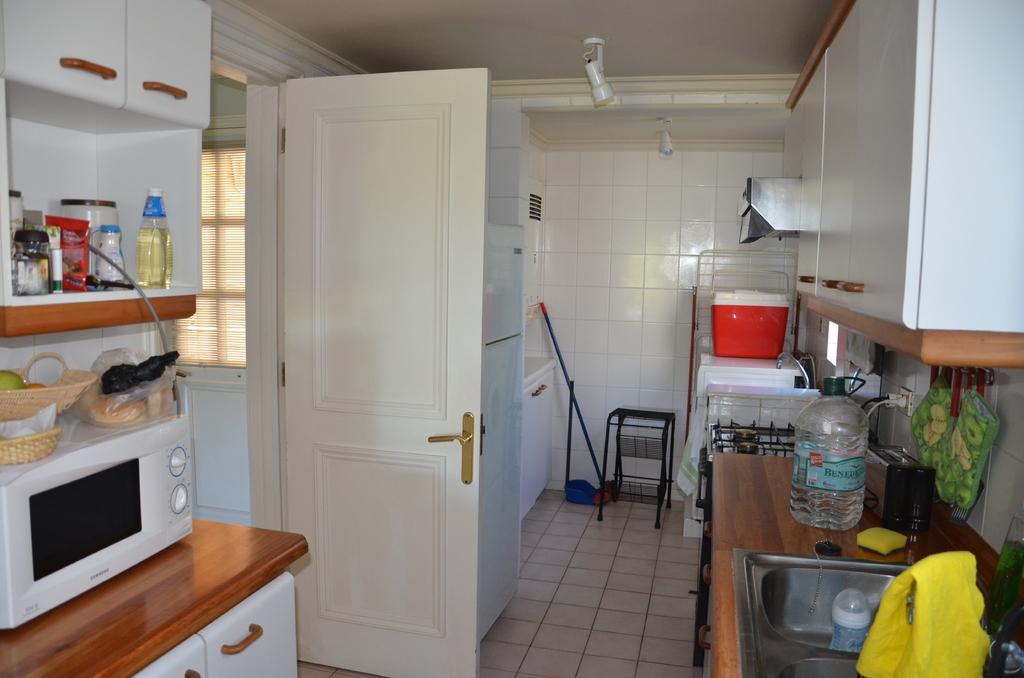Please provide a concise description of this image. In this image, we can see the microwave oven, cupboards, sink, water bubble, refrigerator, baskets, bottles, rods, stove and few objects. At the bottom, there is a floor. Here we can see tile walls and window shade. Top of the image, we can see the ceiling and lights. 